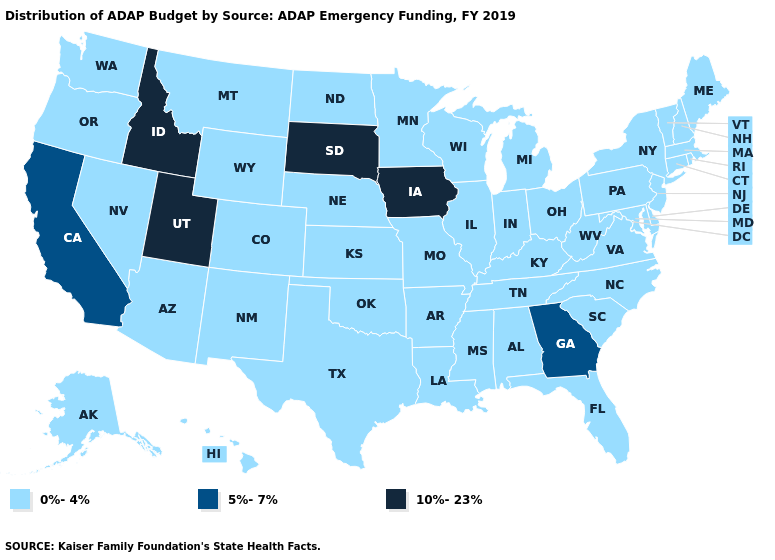What is the highest value in the West ?
Short answer required. 10%-23%. What is the value of Delaware?
Answer briefly. 0%-4%. What is the value of Maine?
Keep it brief. 0%-4%. Among the states that border Texas , which have the highest value?
Quick response, please. Arkansas, Louisiana, New Mexico, Oklahoma. Name the states that have a value in the range 5%-7%?
Concise answer only. California, Georgia. What is the value of Ohio?
Write a very short answer. 0%-4%. What is the lowest value in the Northeast?
Be succinct. 0%-4%. What is the lowest value in the USA?
Short answer required. 0%-4%. Does the first symbol in the legend represent the smallest category?
Short answer required. Yes. What is the value of Nebraska?
Keep it brief. 0%-4%. Which states have the highest value in the USA?
Quick response, please. Idaho, Iowa, South Dakota, Utah. Name the states that have a value in the range 0%-4%?
Quick response, please. Alabama, Alaska, Arizona, Arkansas, Colorado, Connecticut, Delaware, Florida, Hawaii, Illinois, Indiana, Kansas, Kentucky, Louisiana, Maine, Maryland, Massachusetts, Michigan, Minnesota, Mississippi, Missouri, Montana, Nebraska, Nevada, New Hampshire, New Jersey, New Mexico, New York, North Carolina, North Dakota, Ohio, Oklahoma, Oregon, Pennsylvania, Rhode Island, South Carolina, Tennessee, Texas, Vermont, Virginia, Washington, West Virginia, Wisconsin, Wyoming. What is the lowest value in states that border Oklahoma?
Be succinct. 0%-4%. What is the lowest value in states that border North Dakota?
Answer briefly. 0%-4%. What is the lowest value in the Northeast?
Give a very brief answer. 0%-4%. 